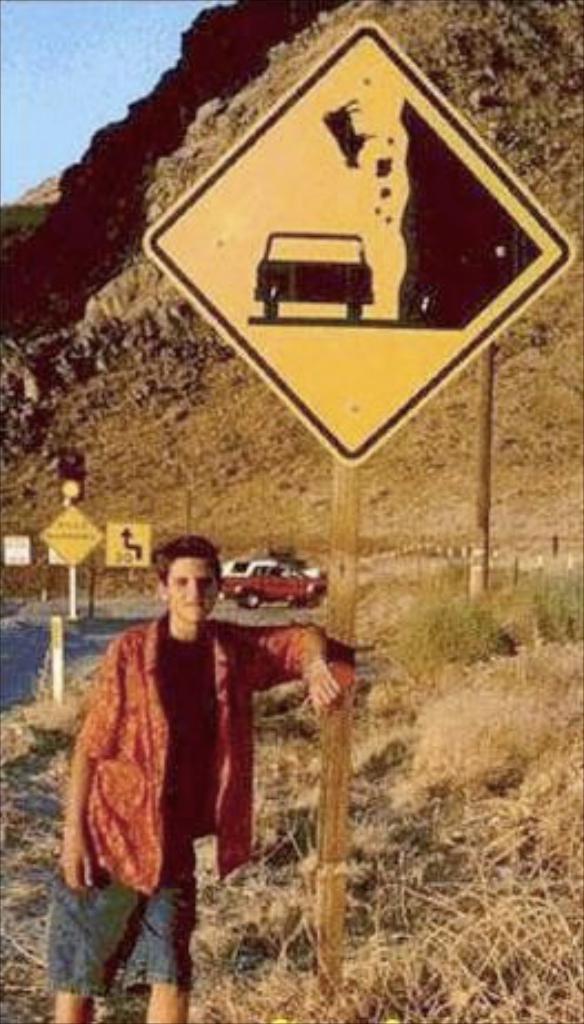Please provide a concise description of this image. In this image we can see a person wearing red color shirt keeping his hands to the signage board and at the background of the image there is vehicle moving on the road, there is mountain and clear sky. 